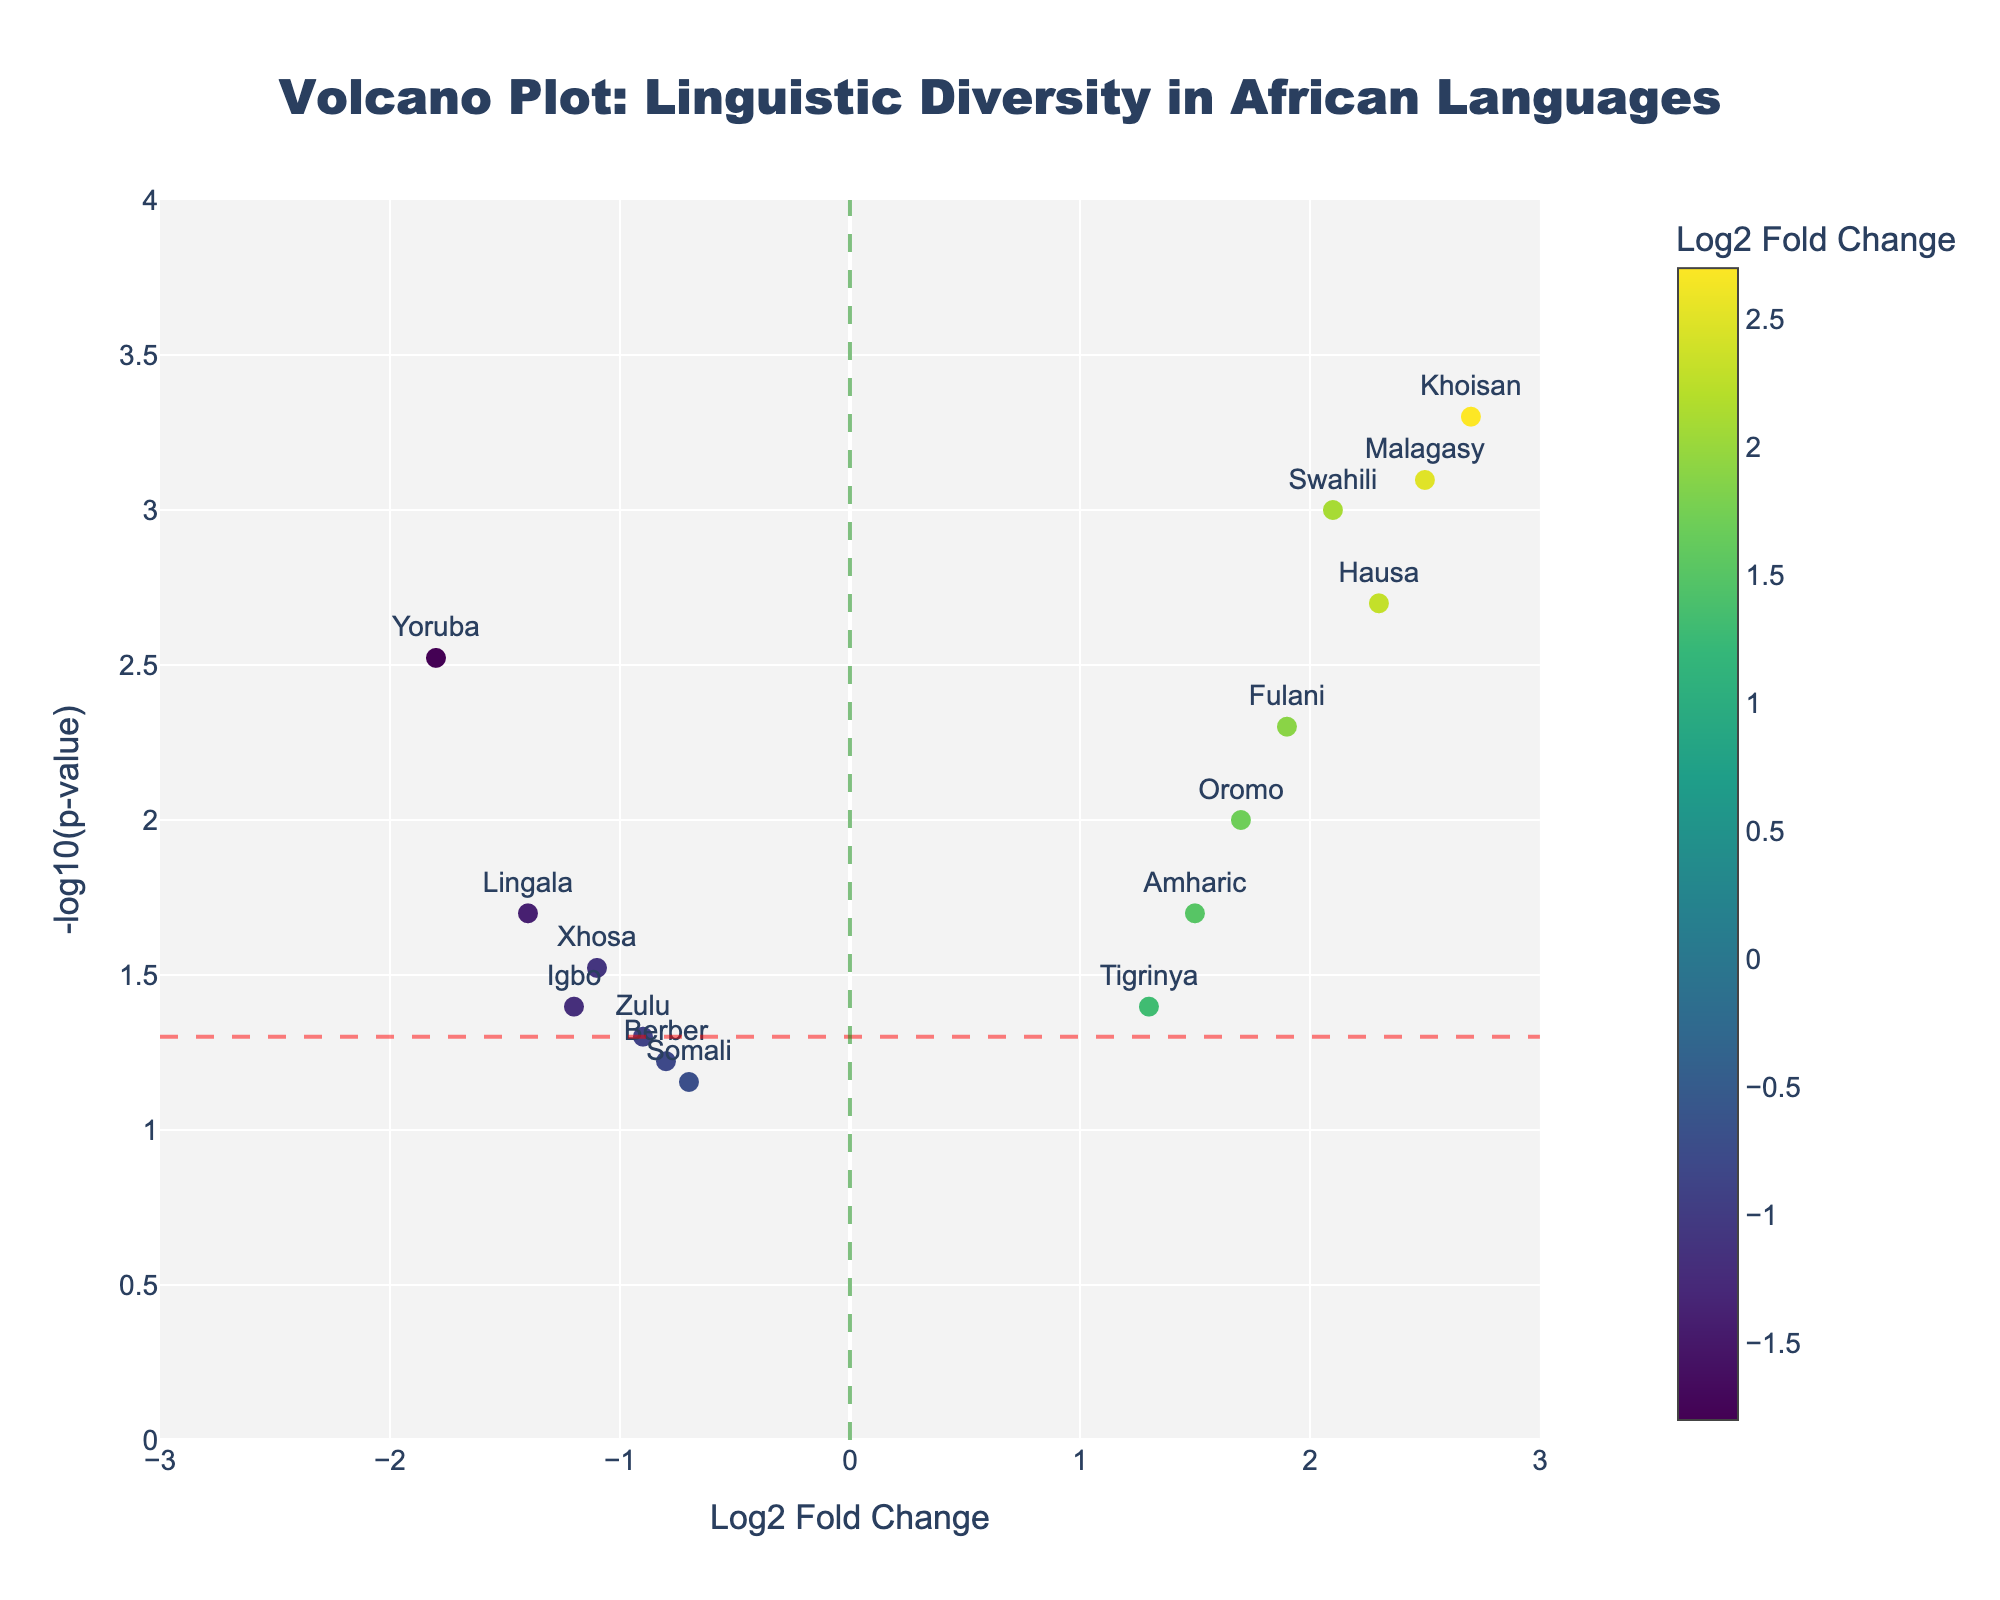How many languages have a positive Log2 Fold Change? Find all the data points positioned to the right of the vertical green line. There are 7 languages with a positive Log2 Fold Change: Swahili, Amharic, Hausa, Oromo, Fulani, Malagasy, and Khoisan.
Answer: 7 Which language has the highest -log10(p-value)? Find the data point with the highest y-axis value (-log10(p-value)). Khoisan has the highest -log10(p-value) with a value indicating the lowest p-value of 0.0005.
Answer: Khoisan Are there more languages with significant p-values (below 0.05) and positive Log2 Fold Change or negative Log2 Fold Change? Count the languages that have y-axis values above the red horizontal line (indicating significant p-values) for both positive and negative Log2 Fold Change regions. There are 5 languages with significant and positive Log2 Fold Change (Swahili, Hausa, Malagasy, Oromo, and Fulani) and 3 languages with significant and negative Log2 Fold Change (Yoruba, Igbo, and Xhosa).
Answer: Positive Which languages have both negative Log2 Fold Change and non-significant p-values (above 0.05)? Look for data points on the left of the vertical green line and below the red horizontal line. There are two languages that meet this criterion: Somali and Berber.
Answer: Somali, Berber What is the log10(p-value) for Zulu? Locate the data point for Zulu on the plot and find its corresponding y-axis value (-log10(p-value)). Zulu has a -log10(p-value) of approximately -log10(0.05).
Answer: ~1.30 How do you identify the cutoff for significant p-values visually in this plot? The significant p-value cutoff is represented by the red horizontal dashed line. Languages above this line have p-values less than 0.05.
Answer: Red dashed line Which language has the lowest Log2 Fold Change among those with significant p-values? Find the language with the lowest x-axis value (Log2 Fold Change) that is also stationed above the red dashed line. Yoruba has the lowest Log2 Fold Change of -1.8 among the significant p-values.
Answer: Yoruba What is the approximate range of the Log2 Fold Change in this plot? The x-axis range for Log2 Fold Change stretches from approximately -3 to 3.
Answer: -3 to 3 Which language shows a significant increase in its representation (high Log2 Fold Change and low p-value)? Identify the language located high on the y-axis and to the right of the vertical green line. Khoisan is a language with a high Log2 Fold Change (2.7) and significant p-value (0.0005).
Answer: Khoisan How many languages have both a non-significant p-value and a negative Log2 Fold Change? Count the points below the red horizontal line and to the left of the vertical green line. There are two languages: Somali and Berber.
Answer: 2 